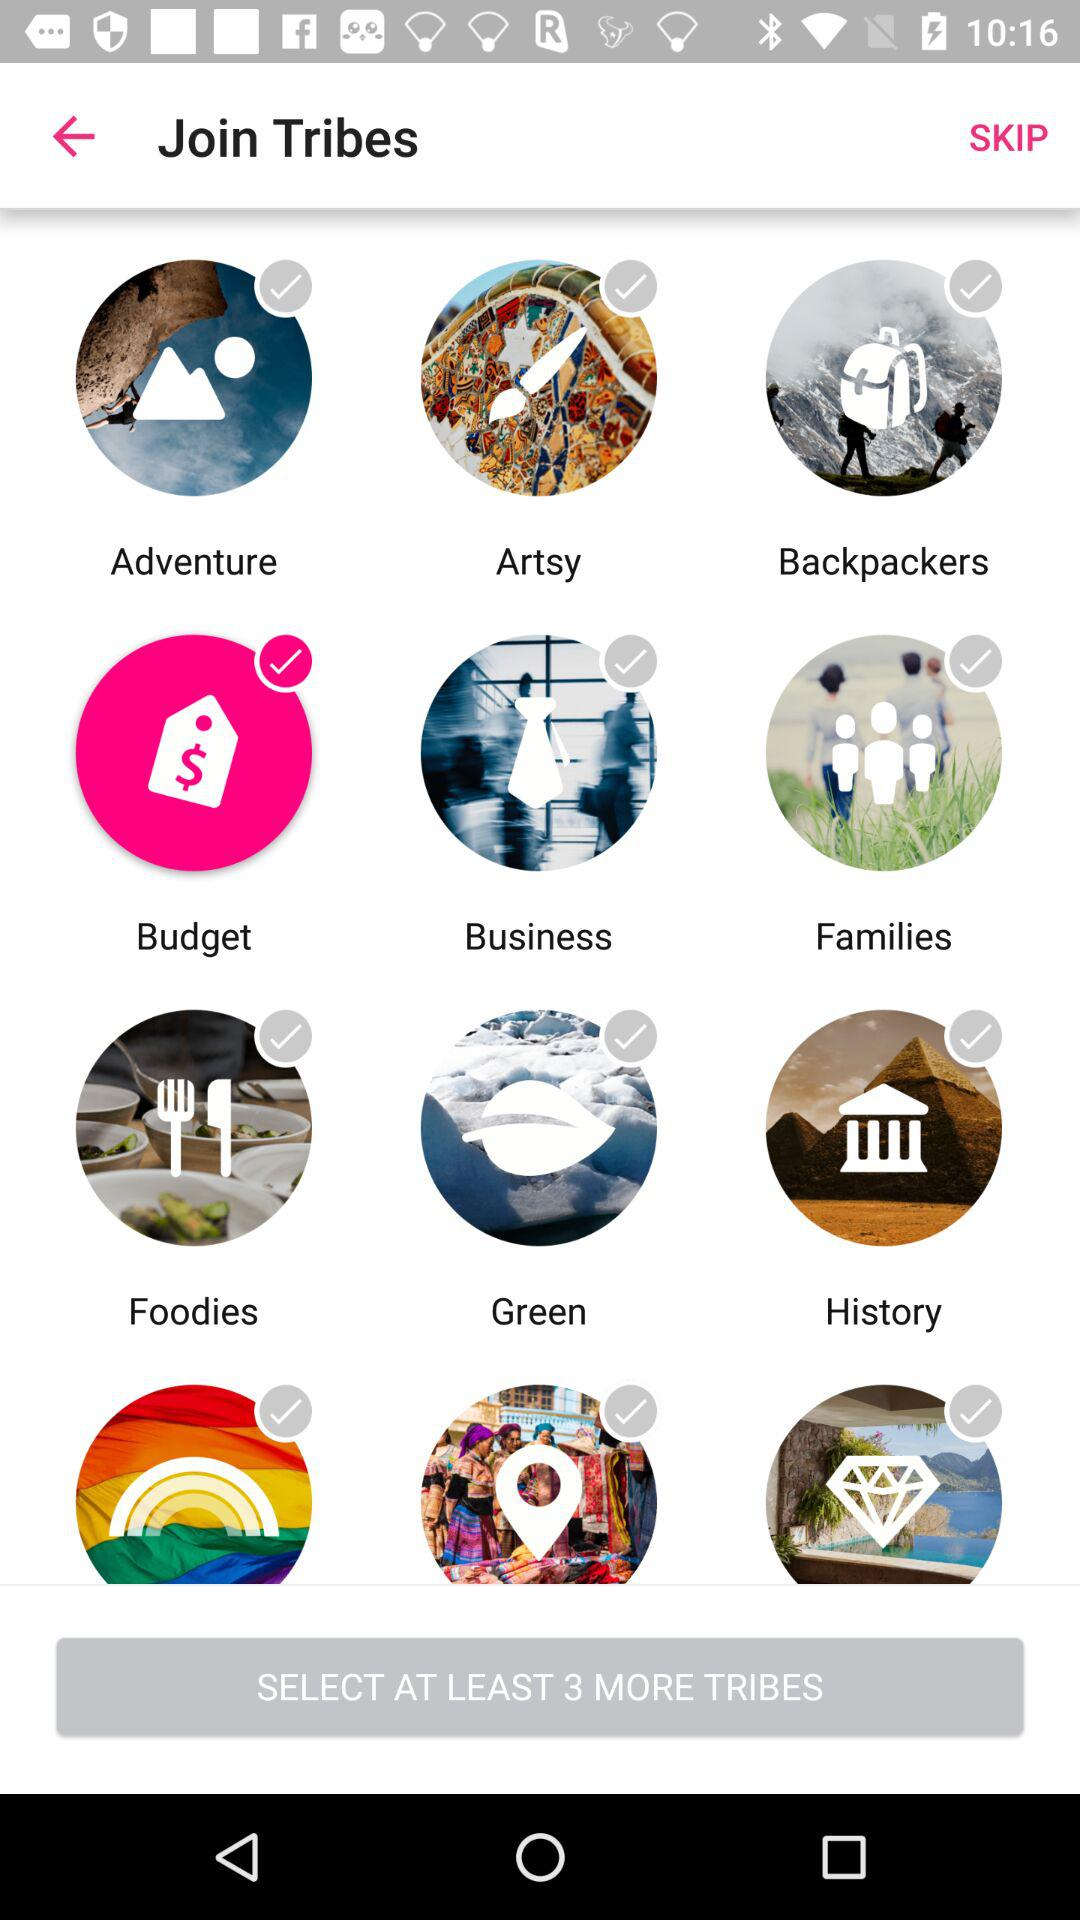What are the different options? The different options are "Adventure", "Artsy", "Backpackers", "Budget", "Business", "Families", "Foodies", "Green" and "History". 